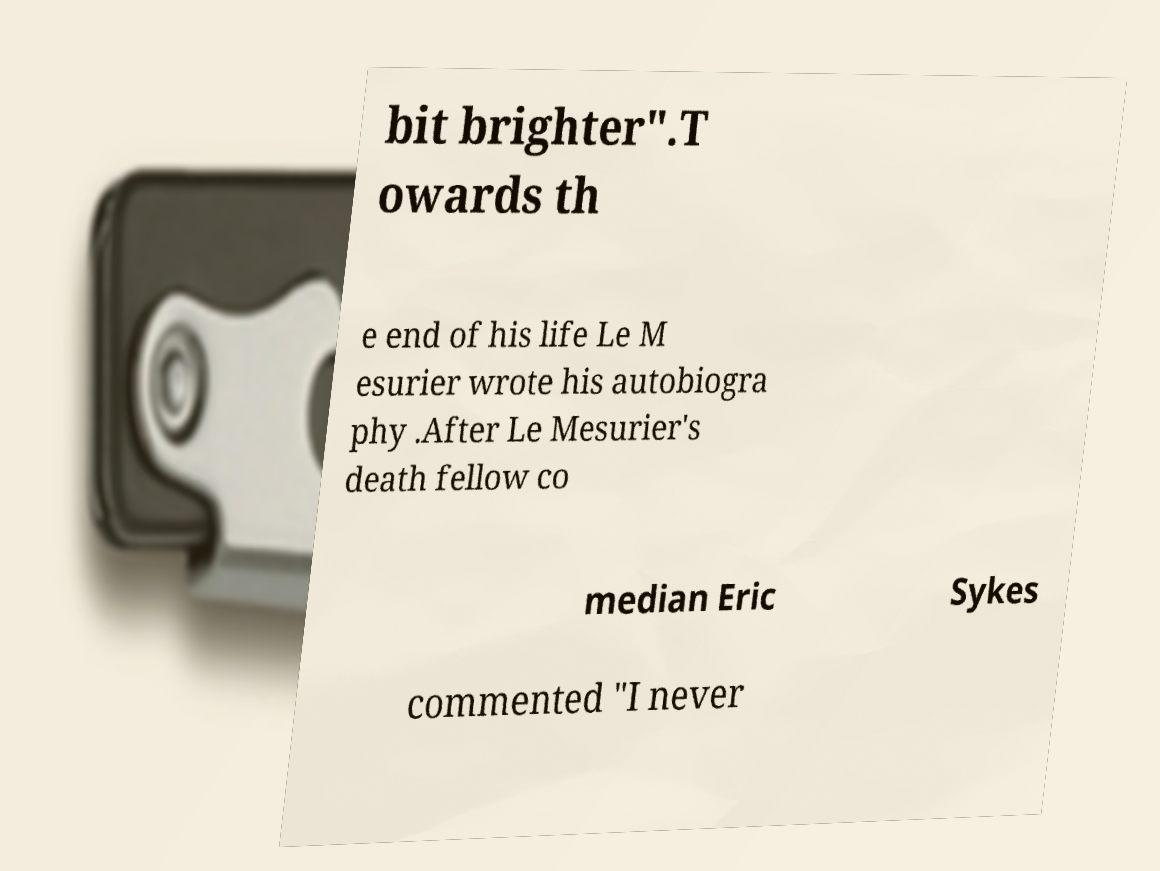There's text embedded in this image that I need extracted. Can you transcribe it verbatim? bit brighter".T owards th e end of his life Le M esurier wrote his autobiogra phy .After Le Mesurier's death fellow co median Eric Sykes commented "I never 